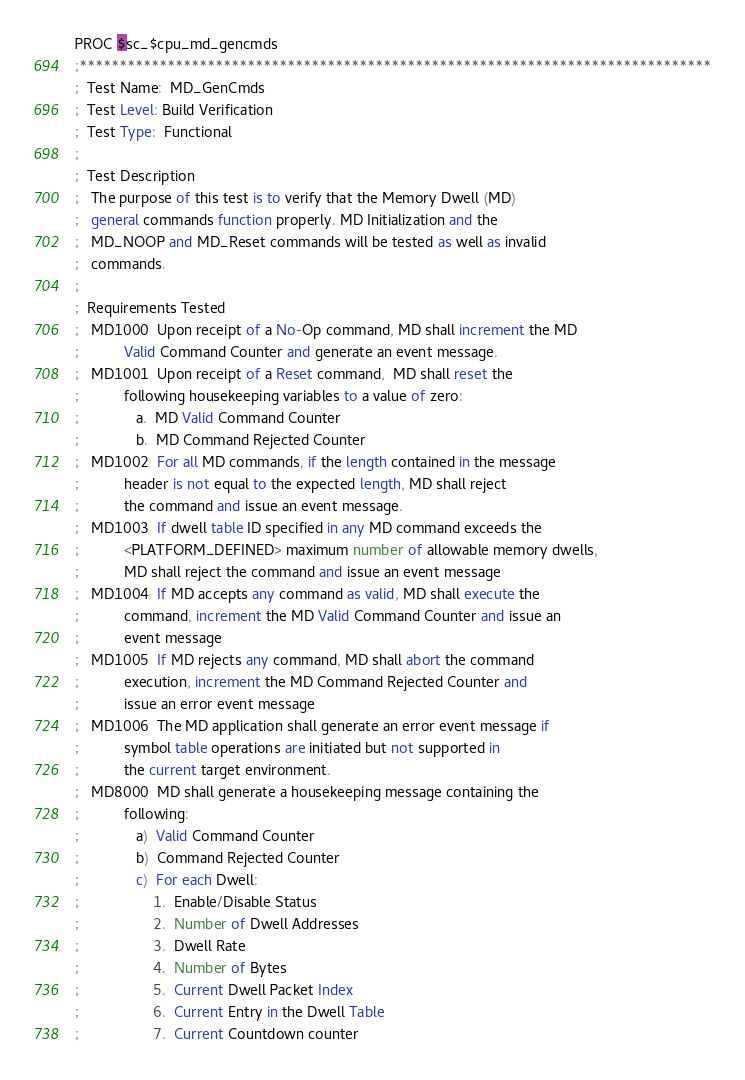Convert code to text. <code><loc_0><loc_0><loc_500><loc_500><_SQL_>PROC $sc_$cpu_md_gencmds
;*******************************************************************************
;  Test Name:  MD_GenCmds
;  Test Level: Build Verification 
;  Test Type:  Functional
;            
;  Test Description
;   The purpose of this test is to verify that the Memory Dwell (MD)
;   general commands function properly. MD Initialization and the
;   MD_NOOP and MD_Reset commands will be tested as well as invalid
;   commands.
;
;  Requirements Tested
;   MD1000  Upon receipt of a No-Op command, MD shall increment the MD
;           Valid Command Counter and generate an event message.
;   MD1001  Upon receipt of a Reset command,  MD shall reset the
;           following housekeeping variables to a value of zero:
;              a.  MD Valid Command Counter
;              b.  MD Command Rejected Counter
;   MD1002  For all MD commands, if the length contained in the message
;           header is not equal to the expected length, MD shall reject
;           the command and issue an event message.
;   MD1003  If dwell table ID specified in any MD command exceeds the
;           <PLATFORM_DEFINED> maximum number of allowable memory dwells,
;           MD shall reject the command and issue an event message
;   MD1004  If MD accepts any command as valid, MD shall execute the
;           command, increment the MD Valid Command Counter and issue an
;           event message
;   MD1005  If MD rejects any command, MD shall abort the command
;           execution, increment the MD Command Rejected Counter and
;           issue an error event message
;   MD1006  The MD application shall generate an error event message if
;           symbol table operations are initiated but not supported in
;           the current target environment.
;   MD8000  MD shall generate a housekeeping message containing the
;           following:
;              a)  Valid Command Counter
;              b)  Command Rejected Counter
;              c)  For each Dwell:
;                  1.  Enable/Disable Status
;                  2.  Number of Dwell Addresses
;                  3.  Dwell Rate
;                  4.  Number of Bytes
;                  5.  Current Dwell Packet Index
;                  6.  Current Entry in the Dwell Table
;                  7.  Current Countdown counter</code> 